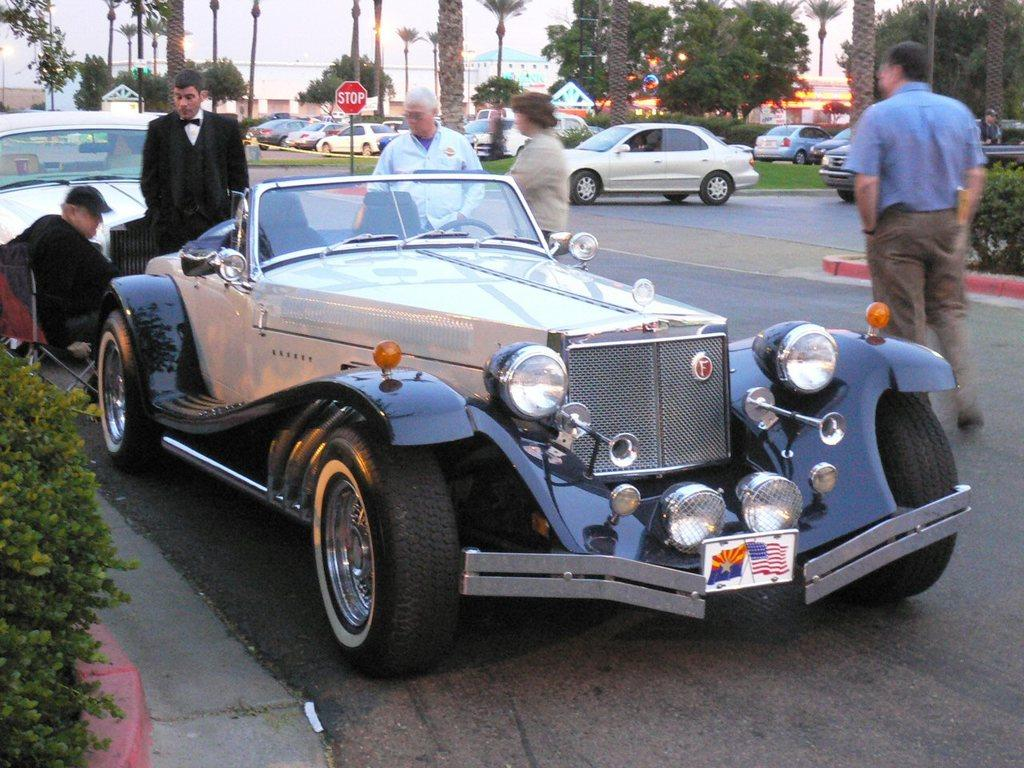What type of vehicles can be seen on the road in the image? There are cars on the road in the image. What else can be seen on the road besides cars? There are people standing on the road in the image. What can be seen in the background of the image? There are trees and the sky visible in the background of the image. What type of produce is being sold at the price displayed on the sign in the image? There is no sign or produce present in the image; it only features cars, people, trees, and the sky. 